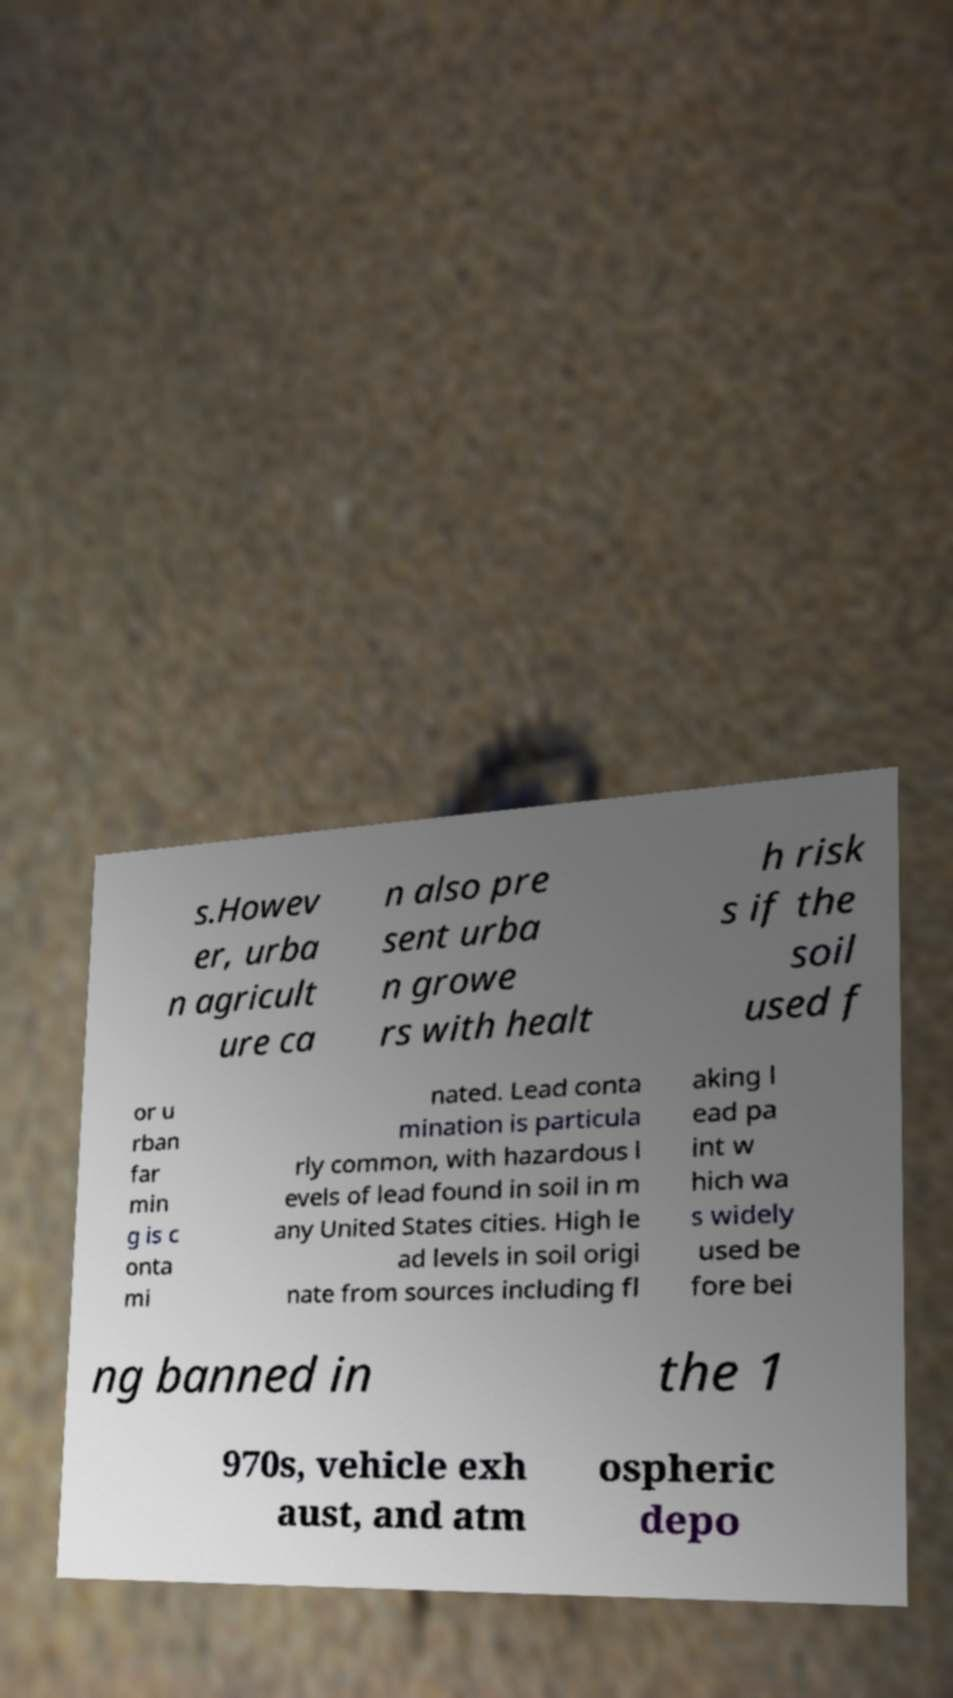Can you accurately transcribe the text from the provided image for me? s.Howev er, urba n agricult ure ca n also pre sent urba n growe rs with healt h risk s if the soil used f or u rban far min g is c onta mi nated. Lead conta mination is particula rly common, with hazardous l evels of lead found in soil in m any United States cities. High le ad levels in soil origi nate from sources including fl aking l ead pa int w hich wa s widely used be fore bei ng banned in the 1 970s, vehicle exh aust, and atm ospheric depo 